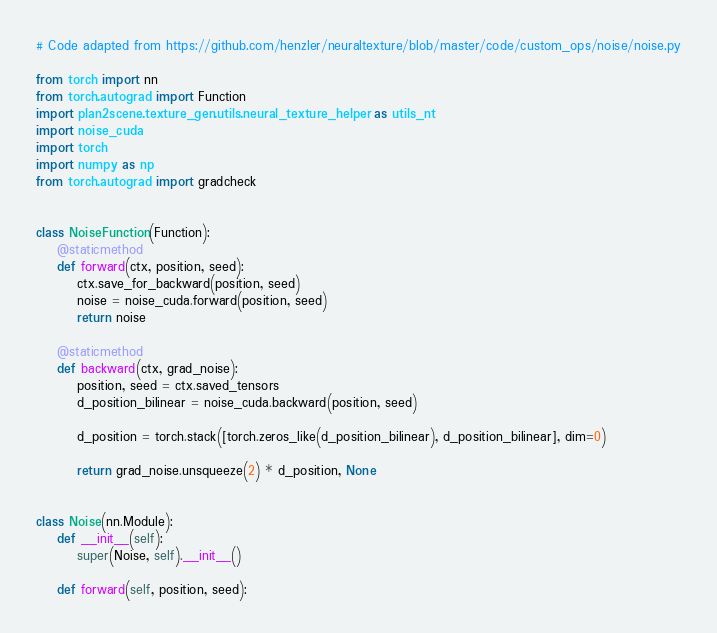Convert code to text. <code><loc_0><loc_0><loc_500><loc_500><_Python_># Code adapted from https://github.com/henzler/neuraltexture/blob/master/code/custom_ops/noise/noise.py

from torch import nn
from torch.autograd import Function
import plan2scene.texture_gen.utils.neural_texture_helper as utils_nt
import noise_cuda
import torch
import numpy as np
from torch.autograd import gradcheck


class NoiseFunction(Function):
    @staticmethod
    def forward(ctx, position, seed):
        ctx.save_for_backward(position, seed)
        noise = noise_cuda.forward(position, seed)
        return noise

    @staticmethod
    def backward(ctx, grad_noise):
        position, seed = ctx.saved_tensors
        d_position_bilinear = noise_cuda.backward(position, seed)

        d_position = torch.stack([torch.zeros_like(d_position_bilinear), d_position_bilinear], dim=0)

        return grad_noise.unsqueeze(2) * d_position, None


class Noise(nn.Module):
    def __init__(self):
        super(Noise, self).__init__()

    def forward(self, position, seed):</code> 